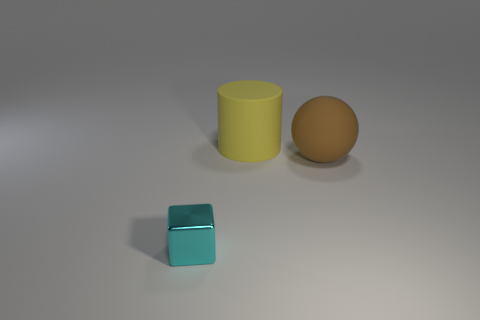What color is the big object that is the same material as the large yellow cylinder?
Offer a very short reply. Brown. There is a object in front of the large matte ball; what size is it?
Make the answer very short. Small. Is the number of yellow cylinders on the right side of the yellow cylinder less than the number of small brown matte blocks?
Offer a terse response. No. Is the large matte sphere the same color as the cylinder?
Your answer should be compact. No. Is there any other thing that is the same shape as the cyan thing?
Give a very brief answer. No. Is the number of large matte balls less than the number of small cyan metal balls?
Provide a short and direct response. No. There is a thing that is behind the big object in front of the big cylinder; what color is it?
Offer a terse response. Yellow. What is the thing behind the thing to the right of the big rubber object that is to the left of the big brown sphere made of?
Offer a terse response. Rubber. There is a object in front of the ball; is it the same size as the large sphere?
Ensure brevity in your answer.  No. What is the object in front of the matte ball made of?
Offer a very short reply. Metal. 